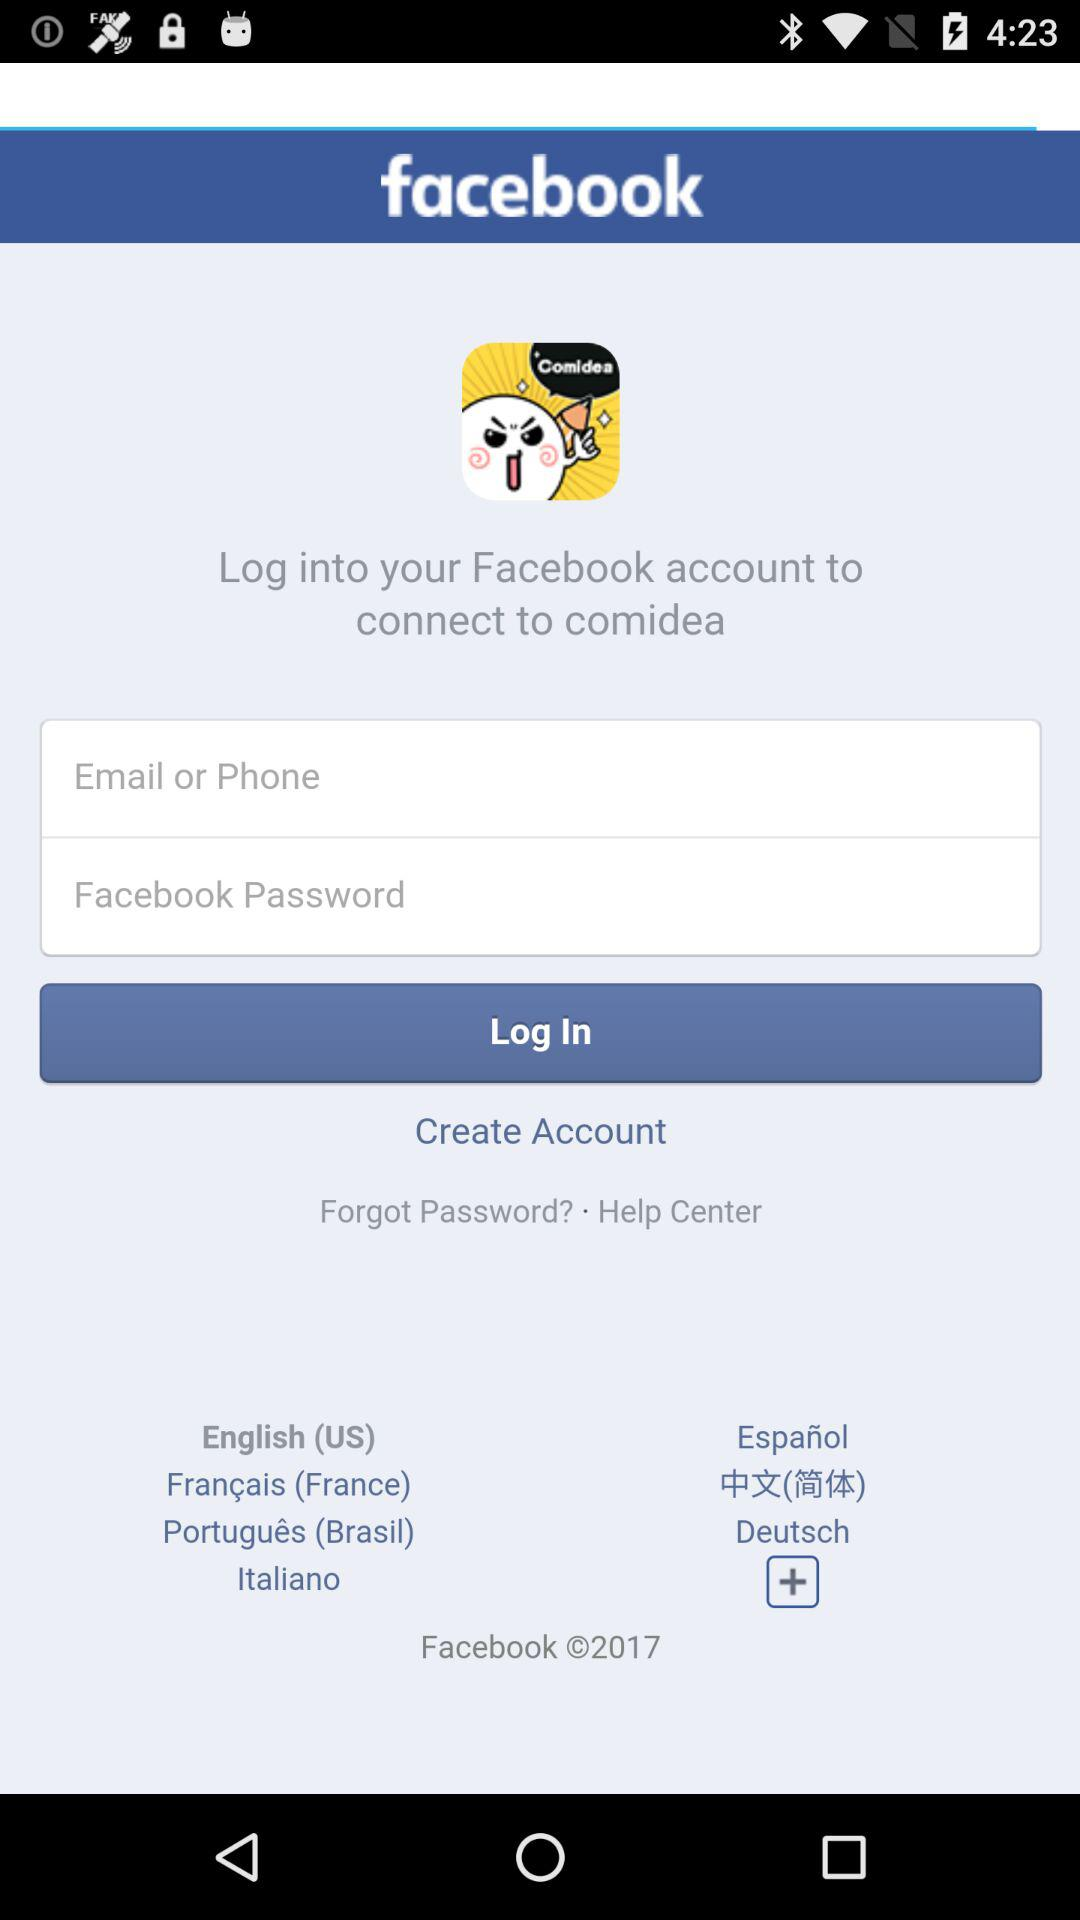What is the application name? The name of the application is "comidea". 